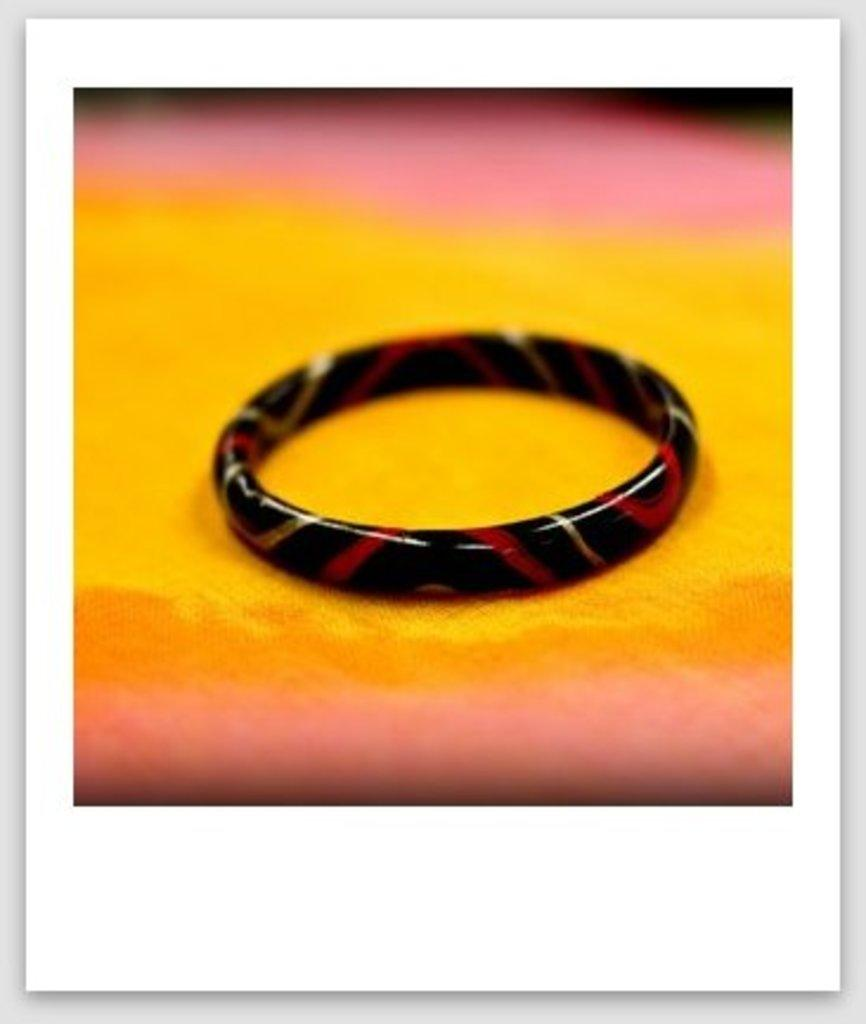How has the image been altered? The image is edited. What type of accessory is present on the cloth in the image? There is a bangle on the cloth in the image. What type of wax can be seen dripping from the bangle in the image? There is no wax present in the image, and the bangle does not appear to be dripping anything. 